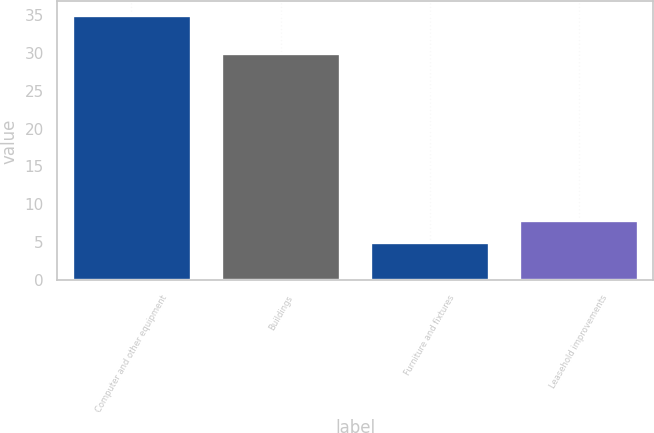Convert chart to OTSL. <chart><loc_0><loc_0><loc_500><loc_500><bar_chart><fcel>Computer and other equipment<fcel>Buildings<fcel>Furniture and fixtures<fcel>Leasehold improvements<nl><fcel>35<fcel>30<fcel>5<fcel>8<nl></chart> 